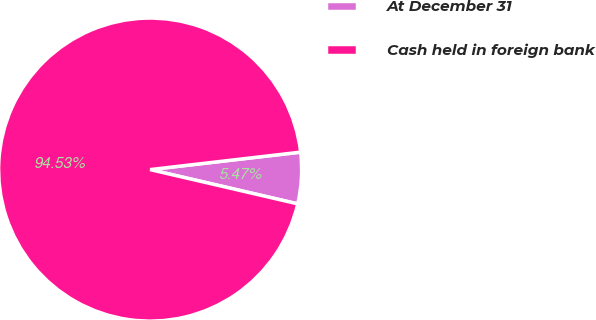Convert chart. <chart><loc_0><loc_0><loc_500><loc_500><pie_chart><fcel>At December 31<fcel>Cash held in foreign bank<nl><fcel>5.47%<fcel>94.53%<nl></chart> 